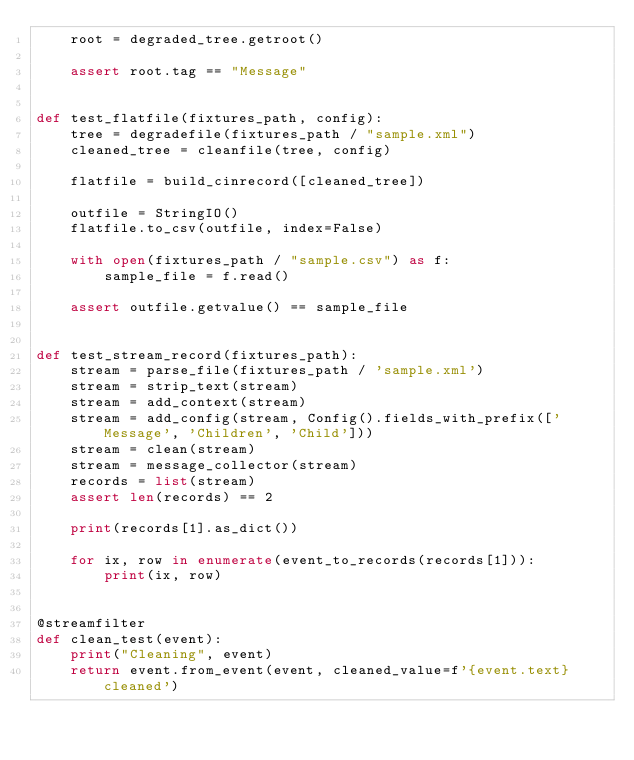<code> <loc_0><loc_0><loc_500><loc_500><_Python_>    root = degraded_tree.getroot()

    assert root.tag == "Message"


def test_flatfile(fixtures_path, config):
    tree = degradefile(fixtures_path / "sample.xml")
    cleaned_tree = cleanfile(tree, config)

    flatfile = build_cinrecord([cleaned_tree])

    outfile = StringIO()
    flatfile.to_csv(outfile, index=False)

    with open(fixtures_path / "sample.csv") as f:
        sample_file = f.read()

    assert outfile.getvalue() == sample_file


def test_stream_record(fixtures_path):
    stream = parse_file(fixtures_path / 'sample.xml')
    stream = strip_text(stream)
    stream = add_context(stream)
    stream = add_config(stream, Config().fields_with_prefix(['Message', 'Children', 'Child']))
    stream = clean(stream)
    stream = message_collector(stream)
    records = list(stream)
    assert len(records) == 2

    print(records[1].as_dict())

    for ix, row in enumerate(event_to_records(records[1])):
        print(ix, row)


@streamfilter
def clean_test(event):
    print("Cleaning", event)
    return event.from_event(event, cleaned_value=f'{event.text} cleaned')
</code> 